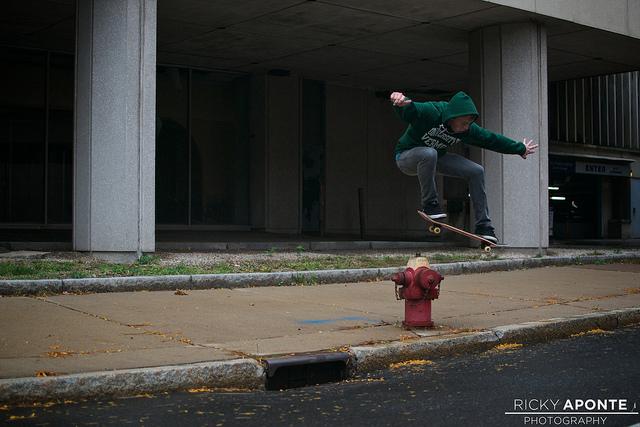What is the wall behind the skateboarder made of?
Write a very short answer. Concrete. What is the name that appears at the bottom right?
Quick response, please. Ricky aponte. Is it raining?
Give a very brief answer. No. Is the person wearing their hood?
Write a very short answer. Yes. What material is the road made of?
Short answer required. Asphalt. What is the color of the hydrant?
Answer briefly. Red. What color is the fire hydrant?
Be succinct. Red. What is surrounding the fire hydrant?
Short answer required. Sidewalk. Is this hydrant working?
Short answer required. Yes. 